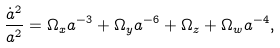Convert formula to latex. <formula><loc_0><loc_0><loc_500><loc_500>\frac { \dot { a } ^ { 2 } } { a ^ { 2 } } = \Omega _ { x } a ^ { - 3 } + \Omega _ { y } a ^ { - 6 } + \Omega _ { z } + \Omega _ { w } a ^ { - 4 } ,</formula> 